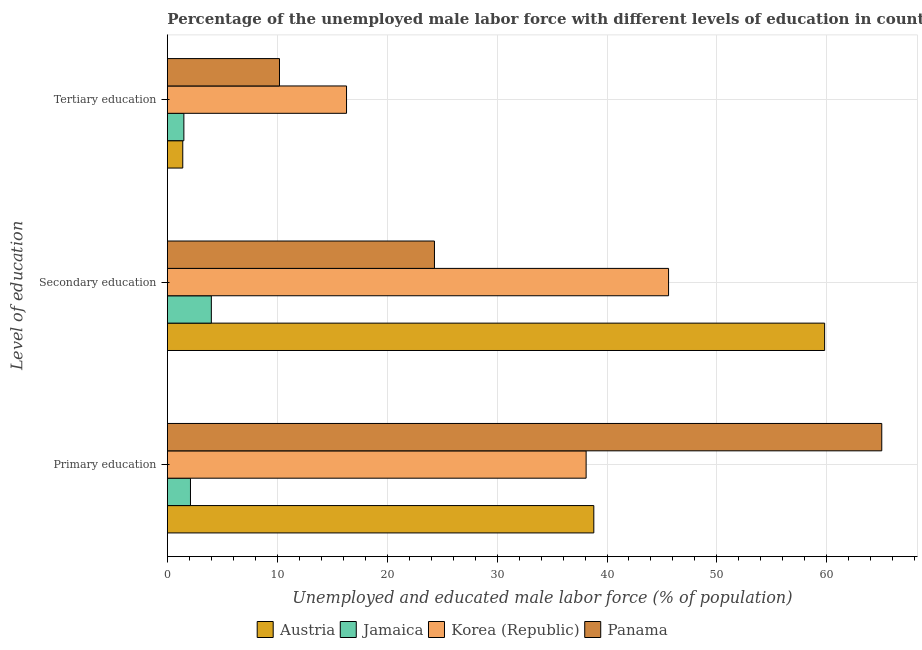How many groups of bars are there?
Offer a very short reply. 3. Are the number of bars per tick equal to the number of legend labels?
Keep it short and to the point. Yes. How many bars are there on the 3rd tick from the bottom?
Your response must be concise. 4. What is the label of the 2nd group of bars from the top?
Provide a short and direct response. Secondary education. Across all countries, what is the maximum percentage of male labor force who received tertiary education?
Make the answer very short. 16.3. What is the total percentage of male labor force who received secondary education in the graph?
Ensure brevity in your answer.  133.7. What is the difference between the percentage of male labor force who received secondary education in Jamaica and that in Austria?
Your response must be concise. -55.8. What is the difference between the percentage of male labor force who received secondary education in Austria and the percentage of male labor force who received tertiary education in Panama?
Make the answer very short. 49.6. What is the average percentage of male labor force who received tertiary education per country?
Offer a very short reply. 7.35. What is the difference between the percentage of male labor force who received secondary education and percentage of male labor force who received primary education in Panama?
Offer a terse response. -40.7. What is the ratio of the percentage of male labor force who received primary education in Jamaica to that in Austria?
Your answer should be very brief. 0.05. Is the percentage of male labor force who received secondary education in Korea (Republic) less than that in Panama?
Ensure brevity in your answer.  No. What is the difference between the highest and the second highest percentage of male labor force who received secondary education?
Offer a very short reply. 14.2. What is the difference between the highest and the lowest percentage of male labor force who received primary education?
Give a very brief answer. 62.9. In how many countries, is the percentage of male labor force who received tertiary education greater than the average percentage of male labor force who received tertiary education taken over all countries?
Ensure brevity in your answer.  2. Is the sum of the percentage of male labor force who received secondary education in Korea (Republic) and Jamaica greater than the maximum percentage of male labor force who received primary education across all countries?
Make the answer very short. No. What does the 3rd bar from the top in Primary education represents?
Your answer should be compact. Jamaica. What does the 2nd bar from the bottom in Primary education represents?
Give a very brief answer. Jamaica. Are all the bars in the graph horizontal?
Keep it short and to the point. Yes. How many countries are there in the graph?
Your answer should be very brief. 4. What is the difference between two consecutive major ticks on the X-axis?
Your answer should be very brief. 10. Are the values on the major ticks of X-axis written in scientific E-notation?
Give a very brief answer. No. Does the graph contain grids?
Offer a very short reply. Yes. How many legend labels are there?
Offer a very short reply. 4. What is the title of the graph?
Offer a terse response. Percentage of the unemployed male labor force with different levels of education in countries. What is the label or title of the X-axis?
Your response must be concise. Unemployed and educated male labor force (% of population). What is the label or title of the Y-axis?
Your answer should be compact. Level of education. What is the Unemployed and educated male labor force (% of population) in Austria in Primary education?
Your answer should be compact. 38.8. What is the Unemployed and educated male labor force (% of population) in Jamaica in Primary education?
Offer a terse response. 2.1. What is the Unemployed and educated male labor force (% of population) of Korea (Republic) in Primary education?
Make the answer very short. 38.1. What is the Unemployed and educated male labor force (% of population) of Austria in Secondary education?
Your answer should be compact. 59.8. What is the Unemployed and educated male labor force (% of population) in Korea (Republic) in Secondary education?
Provide a short and direct response. 45.6. What is the Unemployed and educated male labor force (% of population) of Panama in Secondary education?
Make the answer very short. 24.3. What is the Unemployed and educated male labor force (% of population) of Austria in Tertiary education?
Keep it short and to the point. 1.4. What is the Unemployed and educated male labor force (% of population) in Jamaica in Tertiary education?
Ensure brevity in your answer.  1.5. What is the Unemployed and educated male labor force (% of population) in Korea (Republic) in Tertiary education?
Keep it short and to the point. 16.3. What is the Unemployed and educated male labor force (% of population) of Panama in Tertiary education?
Provide a succinct answer. 10.2. Across all Level of education, what is the maximum Unemployed and educated male labor force (% of population) of Austria?
Your response must be concise. 59.8. Across all Level of education, what is the maximum Unemployed and educated male labor force (% of population) of Jamaica?
Offer a very short reply. 4. Across all Level of education, what is the maximum Unemployed and educated male labor force (% of population) in Korea (Republic)?
Offer a very short reply. 45.6. Across all Level of education, what is the minimum Unemployed and educated male labor force (% of population) in Austria?
Keep it short and to the point. 1.4. Across all Level of education, what is the minimum Unemployed and educated male labor force (% of population) in Jamaica?
Offer a very short reply. 1.5. Across all Level of education, what is the minimum Unemployed and educated male labor force (% of population) in Korea (Republic)?
Provide a short and direct response. 16.3. Across all Level of education, what is the minimum Unemployed and educated male labor force (% of population) in Panama?
Keep it short and to the point. 10.2. What is the total Unemployed and educated male labor force (% of population) in Austria in the graph?
Offer a terse response. 100. What is the total Unemployed and educated male labor force (% of population) of Panama in the graph?
Your answer should be very brief. 99.5. What is the difference between the Unemployed and educated male labor force (% of population) in Austria in Primary education and that in Secondary education?
Ensure brevity in your answer.  -21. What is the difference between the Unemployed and educated male labor force (% of population) in Jamaica in Primary education and that in Secondary education?
Your response must be concise. -1.9. What is the difference between the Unemployed and educated male labor force (% of population) in Panama in Primary education and that in Secondary education?
Your answer should be compact. 40.7. What is the difference between the Unemployed and educated male labor force (% of population) in Austria in Primary education and that in Tertiary education?
Ensure brevity in your answer.  37.4. What is the difference between the Unemployed and educated male labor force (% of population) of Jamaica in Primary education and that in Tertiary education?
Provide a succinct answer. 0.6. What is the difference between the Unemployed and educated male labor force (% of population) in Korea (Republic) in Primary education and that in Tertiary education?
Your answer should be very brief. 21.8. What is the difference between the Unemployed and educated male labor force (% of population) in Panama in Primary education and that in Tertiary education?
Your answer should be compact. 54.8. What is the difference between the Unemployed and educated male labor force (% of population) of Austria in Secondary education and that in Tertiary education?
Make the answer very short. 58.4. What is the difference between the Unemployed and educated male labor force (% of population) of Jamaica in Secondary education and that in Tertiary education?
Your answer should be compact. 2.5. What is the difference between the Unemployed and educated male labor force (% of population) in Korea (Republic) in Secondary education and that in Tertiary education?
Your response must be concise. 29.3. What is the difference between the Unemployed and educated male labor force (% of population) in Austria in Primary education and the Unemployed and educated male labor force (% of population) in Jamaica in Secondary education?
Provide a short and direct response. 34.8. What is the difference between the Unemployed and educated male labor force (% of population) in Jamaica in Primary education and the Unemployed and educated male labor force (% of population) in Korea (Republic) in Secondary education?
Your response must be concise. -43.5. What is the difference between the Unemployed and educated male labor force (% of population) in Jamaica in Primary education and the Unemployed and educated male labor force (% of population) in Panama in Secondary education?
Your answer should be compact. -22.2. What is the difference between the Unemployed and educated male labor force (% of population) in Korea (Republic) in Primary education and the Unemployed and educated male labor force (% of population) in Panama in Secondary education?
Your answer should be compact. 13.8. What is the difference between the Unemployed and educated male labor force (% of population) of Austria in Primary education and the Unemployed and educated male labor force (% of population) of Jamaica in Tertiary education?
Provide a short and direct response. 37.3. What is the difference between the Unemployed and educated male labor force (% of population) of Austria in Primary education and the Unemployed and educated male labor force (% of population) of Korea (Republic) in Tertiary education?
Give a very brief answer. 22.5. What is the difference between the Unemployed and educated male labor force (% of population) of Austria in Primary education and the Unemployed and educated male labor force (% of population) of Panama in Tertiary education?
Give a very brief answer. 28.6. What is the difference between the Unemployed and educated male labor force (% of population) of Korea (Republic) in Primary education and the Unemployed and educated male labor force (% of population) of Panama in Tertiary education?
Provide a short and direct response. 27.9. What is the difference between the Unemployed and educated male labor force (% of population) of Austria in Secondary education and the Unemployed and educated male labor force (% of population) of Jamaica in Tertiary education?
Offer a terse response. 58.3. What is the difference between the Unemployed and educated male labor force (% of population) of Austria in Secondary education and the Unemployed and educated male labor force (% of population) of Korea (Republic) in Tertiary education?
Your answer should be compact. 43.5. What is the difference between the Unemployed and educated male labor force (% of population) of Austria in Secondary education and the Unemployed and educated male labor force (% of population) of Panama in Tertiary education?
Keep it short and to the point. 49.6. What is the difference between the Unemployed and educated male labor force (% of population) in Korea (Republic) in Secondary education and the Unemployed and educated male labor force (% of population) in Panama in Tertiary education?
Provide a succinct answer. 35.4. What is the average Unemployed and educated male labor force (% of population) in Austria per Level of education?
Offer a terse response. 33.33. What is the average Unemployed and educated male labor force (% of population) of Jamaica per Level of education?
Give a very brief answer. 2.53. What is the average Unemployed and educated male labor force (% of population) of Korea (Republic) per Level of education?
Keep it short and to the point. 33.33. What is the average Unemployed and educated male labor force (% of population) of Panama per Level of education?
Ensure brevity in your answer.  33.17. What is the difference between the Unemployed and educated male labor force (% of population) in Austria and Unemployed and educated male labor force (% of population) in Jamaica in Primary education?
Your answer should be compact. 36.7. What is the difference between the Unemployed and educated male labor force (% of population) in Austria and Unemployed and educated male labor force (% of population) in Panama in Primary education?
Provide a succinct answer. -26.2. What is the difference between the Unemployed and educated male labor force (% of population) in Jamaica and Unemployed and educated male labor force (% of population) in Korea (Republic) in Primary education?
Make the answer very short. -36. What is the difference between the Unemployed and educated male labor force (% of population) of Jamaica and Unemployed and educated male labor force (% of population) of Panama in Primary education?
Your answer should be compact. -62.9. What is the difference between the Unemployed and educated male labor force (% of population) in Korea (Republic) and Unemployed and educated male labor force (% of population) in Panama in Primary education?
Offer a terse response. -26.9. What is the difference between the Unemployed and educated male labor force (% of population) in Austria and Unemployed and educated male labor force (% of population) in Jamaica in Secondary education?
Provide a short and direct response. 55.8. What is the difference between the Unemployed and educated male labor force (% of population) of Austria and Unemployed and educated male labor force (% of population) of Panama in Secondary education?
Your answer should be compact. 35.5. What is the difference between the Unemployed and educated male labor force (% of population) of Jamaica and Unemployed and educated male labor force (% of population) of Korea (Republic) in Secondary education?
Offer a very short reply. -41.6. What is the difference between the Unemployed and educated male labor force (% of population) of Jamaica and Unemployed and educated male labor force (% of population) of Panama in Secondary education?
Give a very brief answer. -20.3. What is the difference between the Unemployed and educated male labor force (% of population) in Korea (Republic) and Unemployed and educated male labor force (% of population) in Panama in Secondary education?
Keep it short and to the point. 21.3. What is the difference between the Unemployed and educated male labor force (% of population) in Austria and Unemployed and educated male labor force (% of population) in Jamaica in Tertiary education?
Offer a terse response. -0.1. What is the difference between the Unemployed and educated male labor force (% of population) in Austria and Unemployed and educated male labor force (% of population) in Korea (Republic) in Tertiary education?
Provide a succinct answer. -14.9. What is the difference between the Unemployed and educated male labor force (% of population) of Austria and Unemployed and educated male labor force (% of population) of Panama in Tertiary education?
Make the answer very short. -8.8. What is the difference between the Unemployed and educated male labor force (% of population) of Jamaica and Unemployed and educated male labor force (% of population) of Korea (Republic) in Tertiary education?
Your answer should be very brief. -14.8. What is the difference between the Unemployed and educated male labor force (% of population) of Jamaica and Unemployed and educated male labor force (% of population) of Panama in Tertiary education?
Offer a very short reply. -8.7. What is the ratio of the Unemployed and educated male labor force (% of population) of Austria in Primary education to that in Secondary education?
Your answer should be compact. 0.65. What is the ratio of the Unemployed and educated male labor force (% of population) in Jamaica in Primary education to that in Secondary education?
Your answer should be compact. 0.53. What is the ratio of the Unemployed and educated male labor force (% of population) of Korea (Republic) in Primary education to that in Secondary education?
Offer a very short reply. 0.84. What is the ratio of the Unemployed and educated male labor force (% of population) in Panama in Primary education to that in Secondary education?
Give a very brief answer. 2.67. What is the ratio of the Unemployed and educated male labor force (% of population) in Austria in Primary education to that in Tertiary education?
Your answer should be very brief. 27.71. What is the ratio of the Unemployed and educated male labor force (% of population) of Jamaica in Primary education to that in Tertiary education?
Ensure brevity in your answer.  1.4. What is the ratio of the Unemployed and educated male labor force (% of population) of Korea (Republic) in Primary education to that in Tertiary education?
Your answer should be very brief. 2.34. What is the ratio of the Unemployed and educated male labor force (% of population) in Panama in Primary education to that in Tertiary education?
Make the answer very short. 6.37. What is the ratio of the Unemployed and educated male labor force (% of population) of Austria in Secondary education to that in Tertiary education?
Make the answer very short. 42.71. What is the ratio of the Unemployed and educated male labor force (% of population) of Jamaica in Secondary education to that in Tertiary education?
Ensure brevity in your answer.  2.67. What is the ratio of the Unemployed and educated male labor force (% of population) in Korea (Republic) in Secondary education to that in Tertiary education?
Keep it short and to the point. 2.8. What is the ratio of the Unemployed and educated male labor force (% of population) of Panama in Secondary education to that in Tertiary education?
Keep it short and to the point. 2.38. What is the difference between the highest and the second highest Unemployed and educated male labor force (% of population) in Jamaica?
Offer a terse response. 1.9. What is the difference between the highest and the second highest Unemployed and educated male labor force (% of population) of Korea (Republic)?
Your answer should be very brief. 7.5. What is the difference between the highest and the second highest Unemployed and educated male labor force (% of population) in Panama?
Your answer should be compact. 40.7. What is the difference between the highest and the lowest Unemployed and educated male labor force (% of population) of Austria?
Give a very brief answer. 58.4. What is the difference between the highest and the lowest Unemployed and educated male labor force (% of population) of Jamaica?
Ensure brevity in your answer.  2.5. What is the difference between the highest and the lowest Unemployed and educated male labor force (% of population) of Korea (Republic)?
Your answer should be compact. 29.3. What is the difference between the highest and the lowest Unemployed and educated male labor force (% of population) in Panama?
Your answer should be compact. 54.8. 